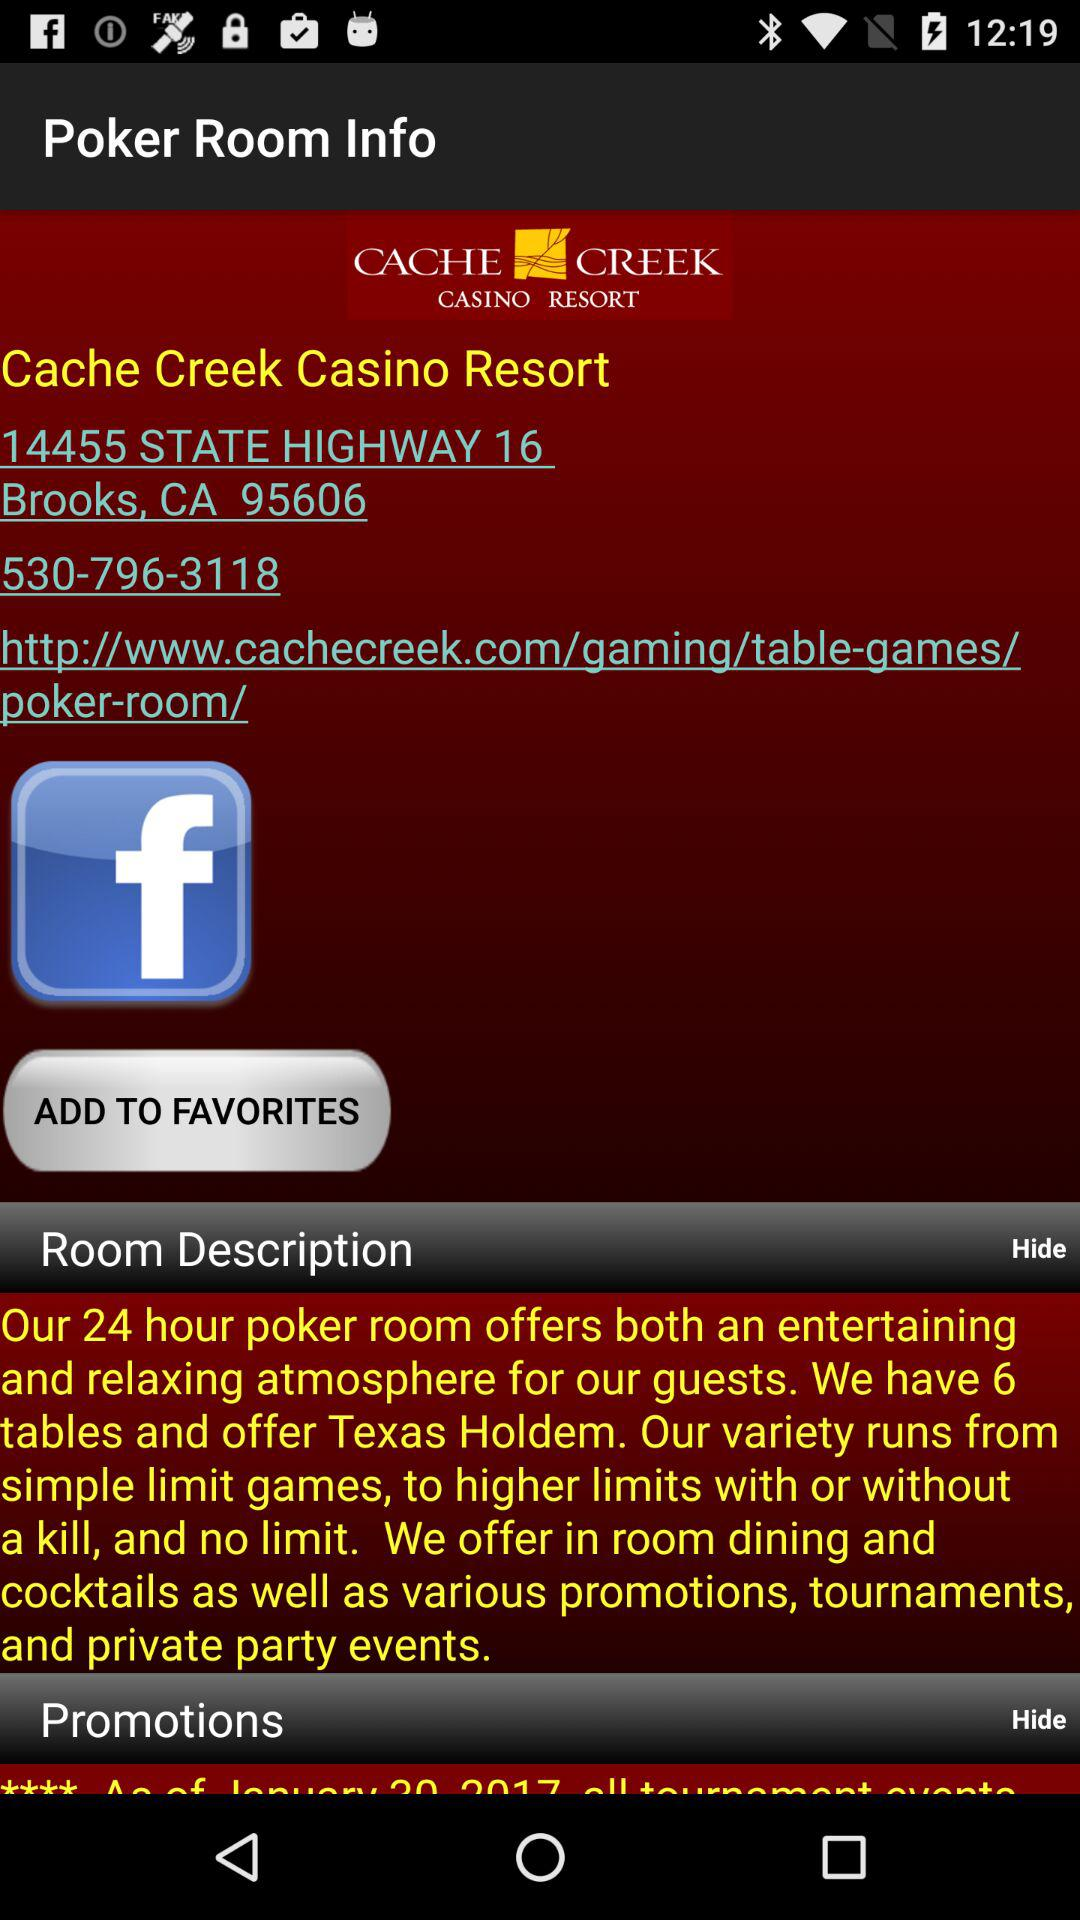How many tables does the poker room have?
Answer the question using a single word or phrase. 6 